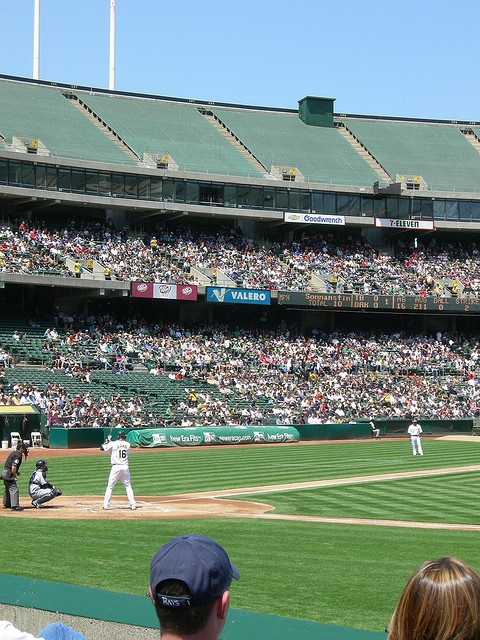Describe the objects in this image and their specific colors. I can see people in lightblue, black, gray, and navy tones, people in lightblue, maroon, black, and gray tones, people in lightblue, white, darkgray, and gray tones, people in lightblue, gray, black, lightgray, and darkgray tones, and people in lightblue, black, gray, darkgray, and darkgreen tones in this image. 